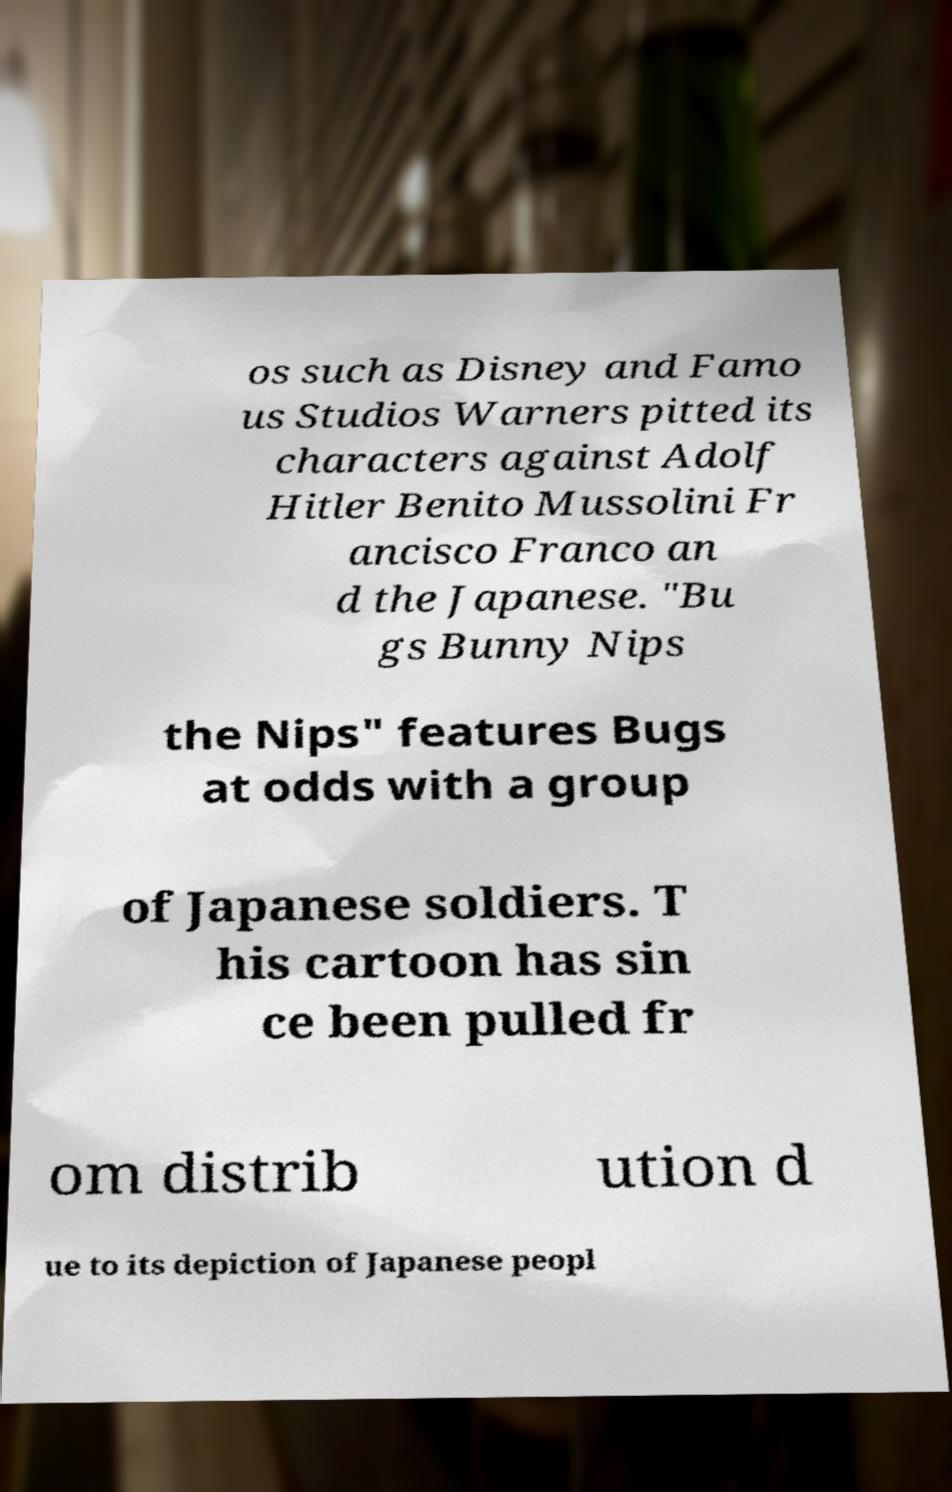I need the written content from this picture converted into text. Can you do that? os such as Disney and Famo us Studios Warners pitted its characters against Adolf Hitler Benito Mussolini Fr ancisco Franco an d the Japanese. "Bu gs Bunny Nips the Nips" features Bugs at odds with a group of Japanese soldiers. T his cartoon has sin ce been pulled fr om distrib ution d ue to its depiction of Japanese peopl 